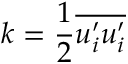Convert formula to latex. <formula><loc_0><loc_0><loc_500><loc_500>k = \frac { 1 } { 2 } \overline { { u _ { i } ^ { \prime } u _ { i } ^ { \prime } } }</formula> 